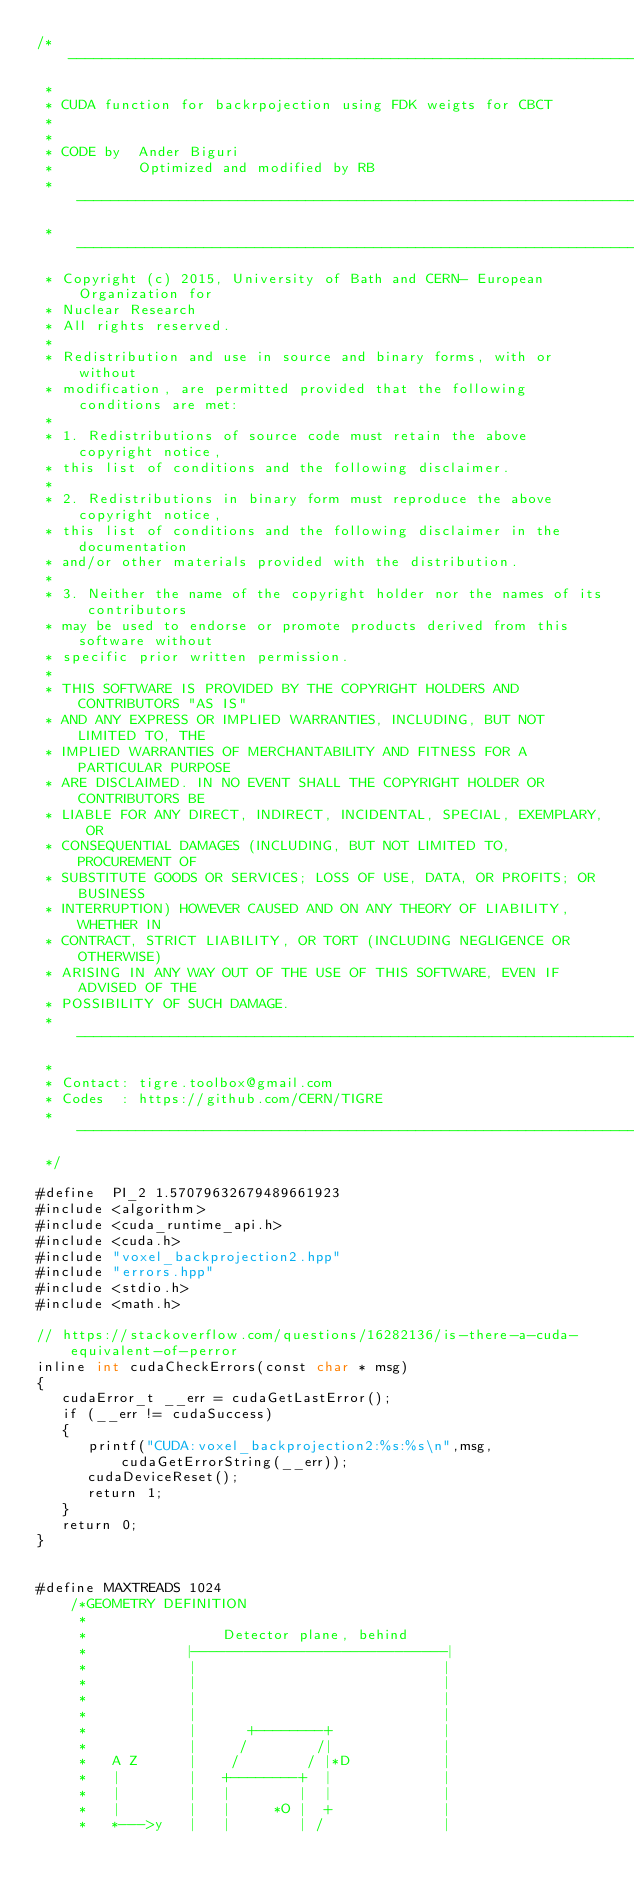Convert code to text. <code><loc_0><loc_0><loc_500><loc_500><_Cuda_>/*-------------------------------------------------------------------------
 *
 * CUDA function for backrpojection using FDK weigts for CBCT
 *
 *
 * CODE by  Ander Biguri
 *          Optimized and modified by RB
 * ---------------------------------------------------------------------------
 * ---------------------------------------------------------------------------
 * Copyright (c) 2015, University of Bath and CERN- European Organization for
 * Nuclear Research
 * All rights reserved.
 *
 * Redistribution and use in source and binary forms, with or without
 * modification, are permitted provided that the following conditions are met:
 *
 * 1. Redistributions of source code must retain the above copyright notice,
 * this list of conditions and the following disclaimer.
 *
 * 2. Redistributions in binary form must reproduce the above copyright notice,
 * this list of conditions and the following disclaimer in the documentation
 * and/or other materials provided with the distribution.
 *
 * 3. Neither the name of the copyright holder nor the names of its contributors
 * may be used to endorse or promote products derived from this software without
 * specific prior written permission.
 *
 * THIS SOFTWARE IS PROVIDED BY THE COPYRIGHT HOLDERS AND CONTRIBUTORS "AS IS"
 * AND ANY EXPRESS OR IMPLIED WARRANTIES, INCLUDING, BUT NOT LIMITED TO, THE
 * IMPLIED WARRANTIES OF MERCHANTABILITY AND FITNESS FOR A PARTICULAR PURPOSE
 * ARE DISCLAIMED. IN NO EVENT SHALL THE COPYRIGHT HOLDER OR CONTRIBUTORS BE
 * LIABLE FOR ANY DIRECT, INDIRECT, INCIDENTAL, SPECIAL, EXEMPLARY, OR
 * CONSEQUENTIAL DAMAGES (INCLUDING, BUT NOT LIMITED TO, PROCUREMENT OF
 * SUBSTITUTE GOODS OR SERVICES; LOSS OF USE, DATA, OR PROFITS; OR BUSINESS
 * INTERRUPTION) HOWEVER CAUSED AND ON ANY THEORY OF LIABILITY, WHETHER IN
 * CONTRACT, STRICT LIABILITY, OR TORT (INCLUDING NEGLIGENCE OR OTHERWISE)
 * ARISING IN ANY WAY OUT OF THE USE OF THIS SOFTWARE, EVEN IF ADVISED OF THE
 * POSSIBILITY OF SUCH DAMAGE.
 * ---------------------------------------------------------------------------
 *
 * Contact: tigre.toolbox@gmail.com
 * Codes  : https://github.com/CERN/TIGRE
 * ---------------------------------------------------------------------------
 */

#define  PI_2 1.57079632679489661923
#include <algorithm>
#include <cuda_runtime_api.h>
#include <cuda.h>
#include "voxel_backprojection2.hpp"
#include "errors.hpp"
#include <stdio.h>
#include <math.h>

// https://stackoverflow.com/questions/16282136/is-there-a-cuda-equivalent-of-perror
inline int cudaCheckErrors(const char * msg)
{
   cudaError_t __err = cudaGetLastError();
   if (__err != cudaSuccess)
   {
      printf("CUDA:voxel_backprojection2:%s:%s\n",msg, cudaGetErrorString(__err));
      cudaDeviceReset();
      return 1;
   }
   return 0;
}
    
    
#define MAXTREADS 1024
    /*GEOMETRY DEFINITION
     *
     *                Detector plane, behind
     *            |-----------------------------|
     *            |                             |
     *            |                             |
     *            |                             |
     *            |                             |
     *            |      +--------+             |
     *            |     /        /|             |
     *   A Z      |    /        / |*D           |
     *   |        |   +--------+  |             |
     *   |        |   |        |  |             |
     *   |        |   |     *O |  +             |
     *   *--->y   |   |        | /              |</code> 